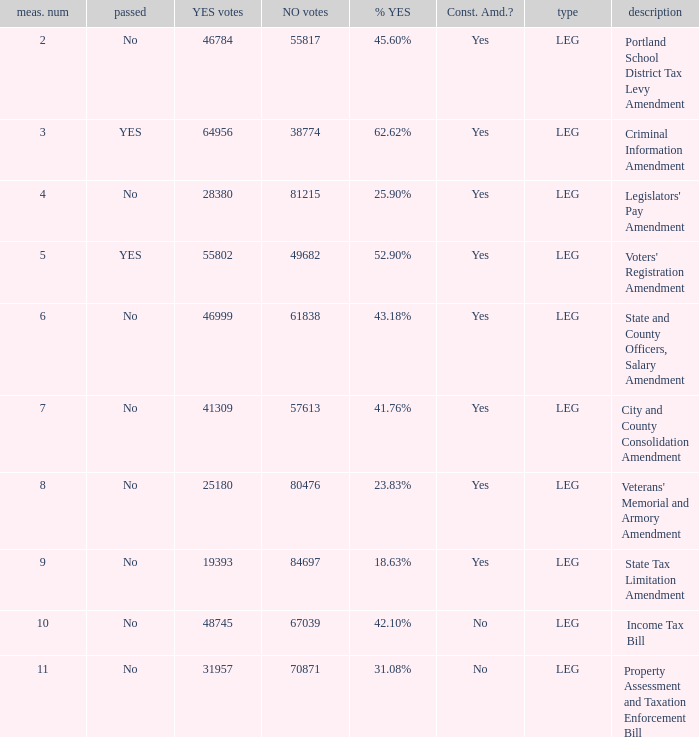Who obtained 41.76% affirmative votes? City and County Consolidation Amendment. Can you parse all the data within this table? {'header': ['meas. num', 'passed', 'YES votes', 'NO votes', '% YES', 'Const. Amd.?', 'type', 'description'], 'rows': [['2', 'No', '46784', '55817', '45.60%', 'Yes', 'LEG', 'Portland School District Tax Levy Amendment'], ['3', 'YES', '64956', '38774', '62.62%', 'Yes', 'LEG', 'Criminal Information Amendment'], ['4', 'No', '28380', '81215', '25.90%', 'Yes', 'LEG', "Legislators' Pay Amendment"], ['5', 'YES', '55802', '49682', '52.90%', 'Yes', 'LEG', "Voters' Registration Amendment"], ['6', 'No', '46999', '61838', '43.18%', 'Yes', 'LEG', 'State and County Officers, Salary Amendment'], ['7', 'No', '41309', '57613', '41.76%', 'Yes', 'LEG', 'City and County Consolidation Amendment'], ['8', 'No', '25180', '80476', '23.83%', 'Yes', 'LEG', "Veterans' Memorial and Armory Amendment"], ['9', 'No', '19393', '84697', '18.63%', 'Yes', 'LEG', 'State Tax Limitation Amendment'], ['10', 'No', '48745', '67039', '42.10%', 'No', 'LEG', 'Income Tax Bill'], ['11', 'No', '31957', '70871', '31.08%', 'No', 'LEG', 'Property Assessment and Taxation Enforcement Bill']]} 